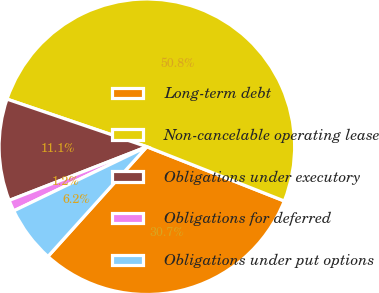Convert chart. <chart><loc_0><loc_0><loc_500><loc_500><pie_chart><fcel>Long-term debt<fcel>Non-cancelable operating lease<fcel>Obligations under executory<fcel>Obligations for deferred<fcel>Obligations under put options<nl><fcel>30.69%<fcel>50.76%<fcel>11.14%<fcel>1.23%<fcel>6.18%<nl></chart> 